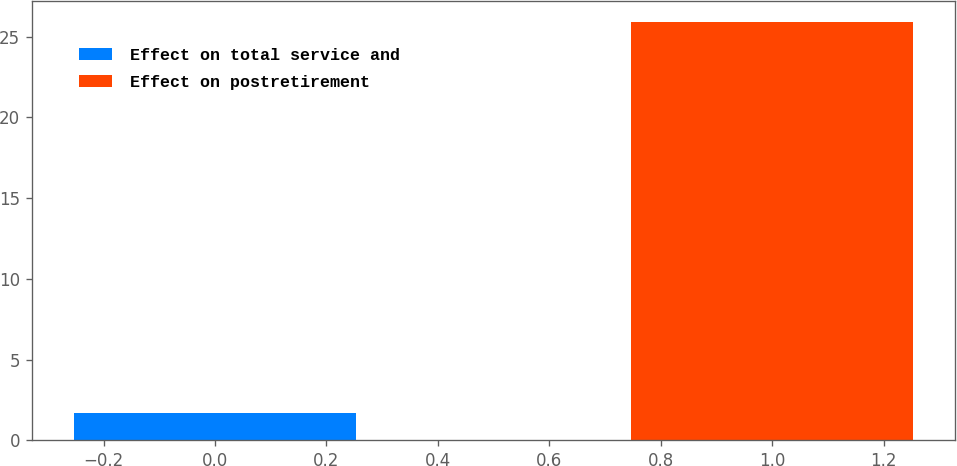<chart> <loc_0><loc_0><loc_500><loc_500><bar_chart><fcel>Effect on total service and<fcel>Effect on postretirement<nl><fcel>1.7<fcel>25.9<nl></chart> 